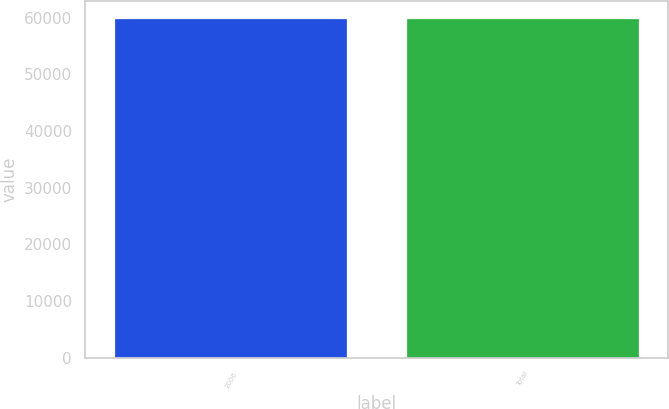Convert chart to OTSL. <chart><loc_0><loc_0><loc_500><loc_500><bar_chart><fcel>2006<fcel>Total<nl><fcel>59960<fcel>59960.1<nl></chart> 